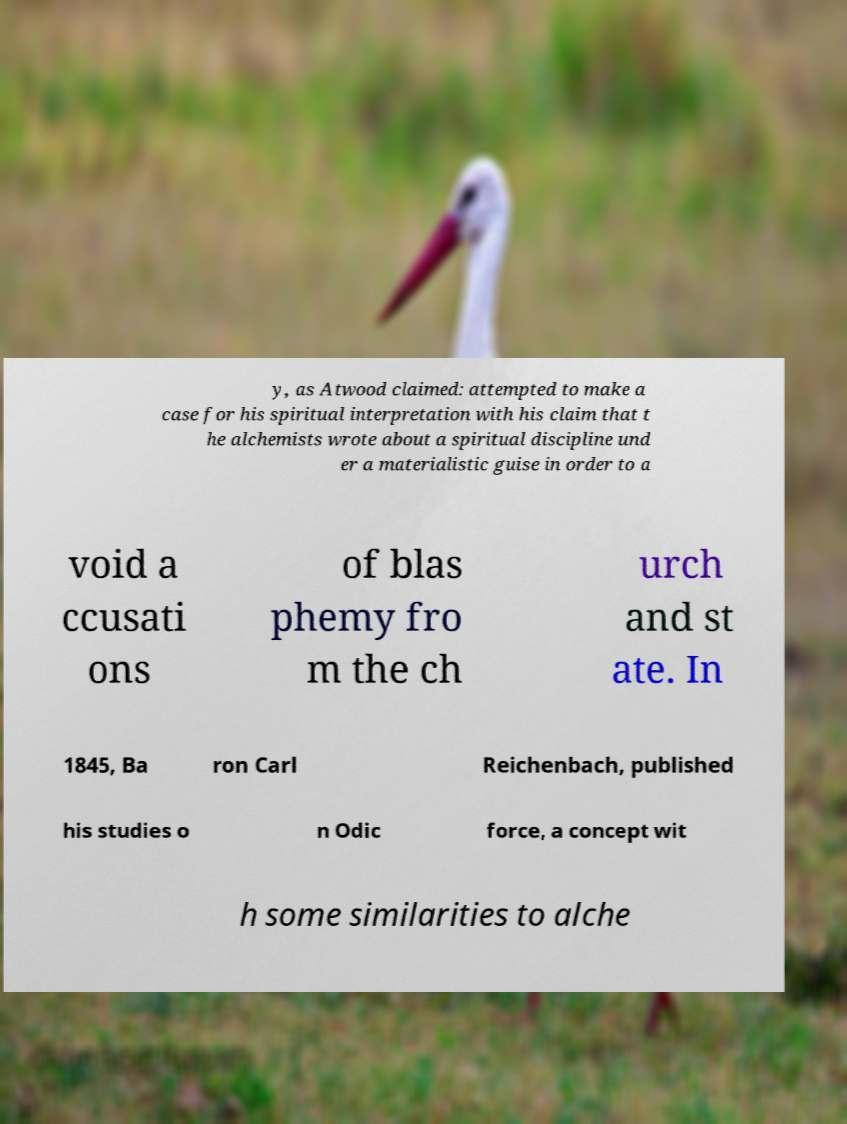For documentation purposes, I need the text within this image transcribed. Could you provide that? y, as Atwood claimed: attempted to make a case for his spiritual interpretation with his claim that t he alchemists wrote about a spiritual discipline und er a materialistic guise in order to a void a ccusati ons of blas phemy fro m the ch urch and st ate. In 1845, Ba ron Carl Reichenbach, published his studies o n Odic force, a concept wit h some similarities to alche 